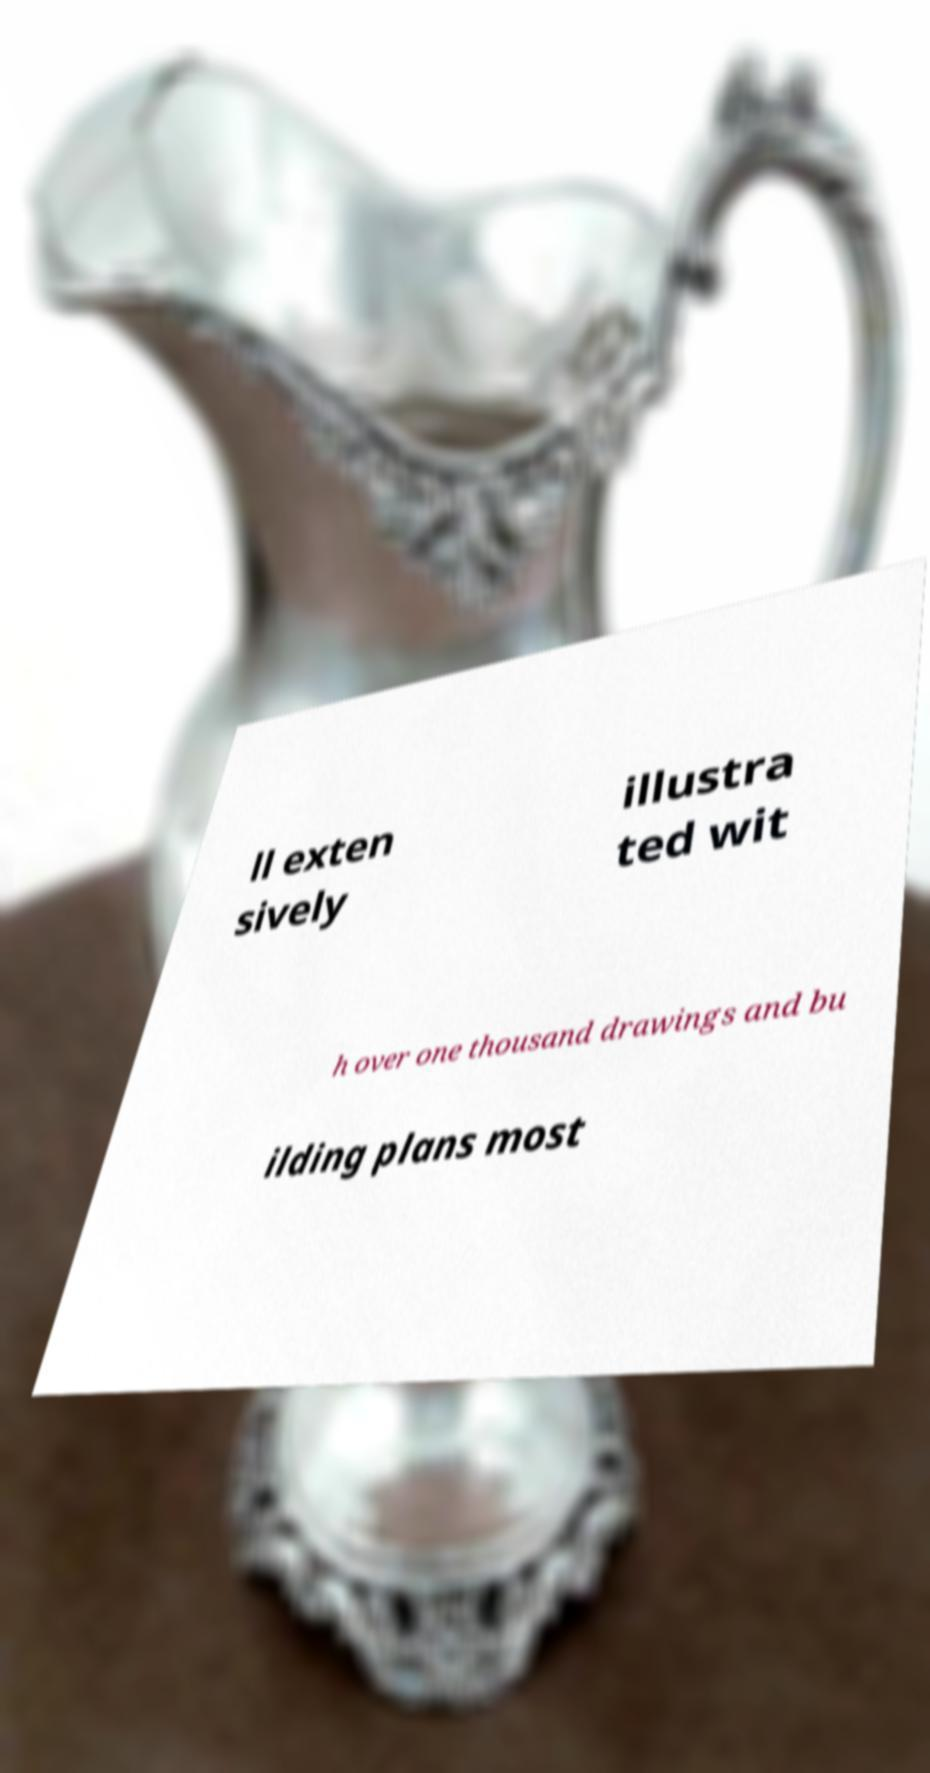There's text embedded in this image that I need extracted. Can you transcribe it verbatim? ll exten sively illustra ted wit h over one thousand drawings and bu ilding plans most 